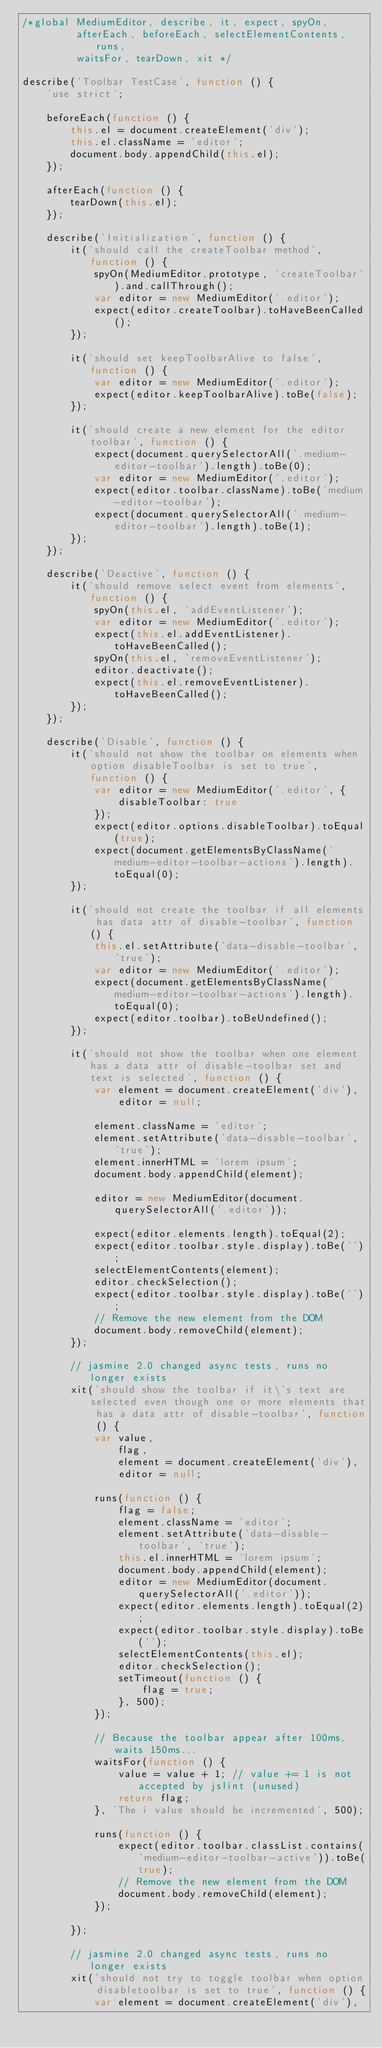<code> <loc_0><loc_0><loc_500><loc_500><_JavaScript_>/*global MediumEditor, describe, it, expect, spyOn,
         afterEach, beforeEach, selectElementContents, runs,
         waitsFor, tearDown, xit */

describe('Toolbar TestCase', function () {
    'use strict';

    beforeEach(function () {
        this.el = document.createElement('div');
        this.el.className = 'editor';
        document.body.appendChild(this.el);
    });

    afterEach(function () {
        tearDown(this.el);
    });

    describe('Initialization', function () {
        it('should call the createToolbar method', function () {
            spyOn(MediumEditor.prototype, 'createToolbar').and.callThrough();
            var editor = new MediumEditor('.editor');
            expect(editor.createToolbar).toHaveBeenCalled();
        });

        it('should set keepToolbarAlive to false', function () {
            var editor = new MediumEditor('.editor');
            expect(editor.keepToolbarAlive).toBe(false);
        });

        it('should create a new element for the editor toolbar', function () {
            expect(document.querySelectorAll('.medium-editor-toolbar').length).toBe(0);
            var editor = new MediumEditor('.editor');
            expect(editor.toolbar.className).toBe('medium-editor-toolbar');
            expect(document.querySelectorAll('.medium-editor-toolbar').length).toBe(1);
        });
    });

    describe('Deactive', function () {
        it('should remove select event from elements', function () {
            spyOn(this.el, 'addEventListener');
            var editor = new MediumEditor('.editor');
            expect(this.el.addEventListener).toHaveBeenCalled();
            spyOn(this.el, 'removeEventListener');
            editor.deactivate();
            expect(this.el.removeEventListener).toHaveBeenCalled();
        });
    });

    describe('Disable', function () {
        it('should not show the toolbar on elements when option disableToolbar is set to true', function () {
            var editor = new MediumEditor('.editor', {
                disableToolbar: true
            });
            expect(editor.options.disableToolbar).toEqual(true);
            expect(document.getElementsByClassName('medium-editor-toolbar-actions').length).toEqual(0);
        });

        it('should not create the toolbar if all elements has data attr of disable-toolbar', function () {
            this.el.setAttribute('data-disable-toolbar', 'true');
            var editor = new MediumEditor('.editor');
            expect(document.getElementsByClassName('medium-editor-toolbar-actions').length).toEqual(0);
            expect(editor.toolbar).toBeUndefined();
        });

        it('should not show the toolbar when one element has a data attr of disable-toolbar set and text is selected', function () {
            var element = document.createElement('div'),
                editor = null;

            element.className = 'editor';
            element.setAttribute('data-disable-toolbar', 'true');
            element.innerHTML = 'lorem ipsum';
            document.body.appendChild(element);

            editor = new MediumEditor(document.querySelectorAll('.editor'));

            expect(editor.elements.length).toEqual(2);
            expect(editor.toolbar.style.display).toBe('');
            selectElementContents(element);
            editor.checkSelection();
            expect(editor.toolbar.style.display).toBe('');
            // Remove the new element from the DOM
            document.body.removeChild(element);
        });

        // jasmine 2.0 changed async tests, runs no longer exists
        xit('should show the toolbar if it\'s text are selected even though one or more elements that has a data attr of disable-toolbar', function () {
            var value,
                flag,
                element = document.createElement('div'),
                editor = null;

            runs(function () {
                flag = false;
                element.className = 'editor';
                element.setAttribute('data-disable-toolbar', 'true');
                this.el.innerHTML = 'lorem ipsum';
                document.body.appendChild(element);
                editor = new MediumEditor(document.querySelectorAll('.editor'));
                expect(editor.elements.length).toEqual(2);
                expect(editor.toolbar.style.display).toBe('');
                selectElementContents(this.el);
                editor.checkSelection();
                setTimeout(function () {
                    flag = true;
                }, 500);
            });

            // Because the toolbar appear after 100ms, waits 150ms... 
            waitsFor(function () {
                value = value + 1; // value += 1 is not accepted by jslint (unused)
                return flag;
            }, 'The i value should be incremented', 500);

            runs(function () {
                expect(editor.toolbar.classList.contains('medium-editor-toolbar-active')).toBe(true);
                // Remove the new element from the DOM
                document.body.removeChild(element);
            });

        });

        // jasmine 2.0 changed async tests, runs no longer exists
        xit('should not try to toggle toolbar when option disabletoolbar is set to true', function () {
            var element = document.createElement('div'),</code> 